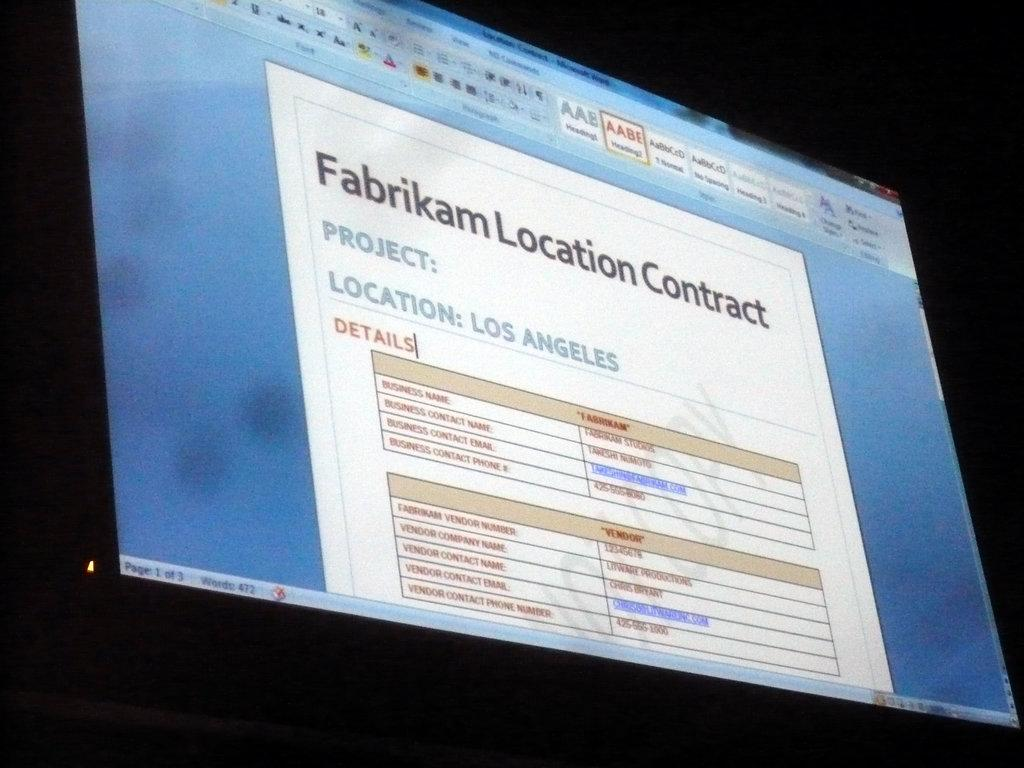<image>
Give a short and clear explanation of the subsequent image. A monitor displays a shot of a contract in the location of Los Angeles. 